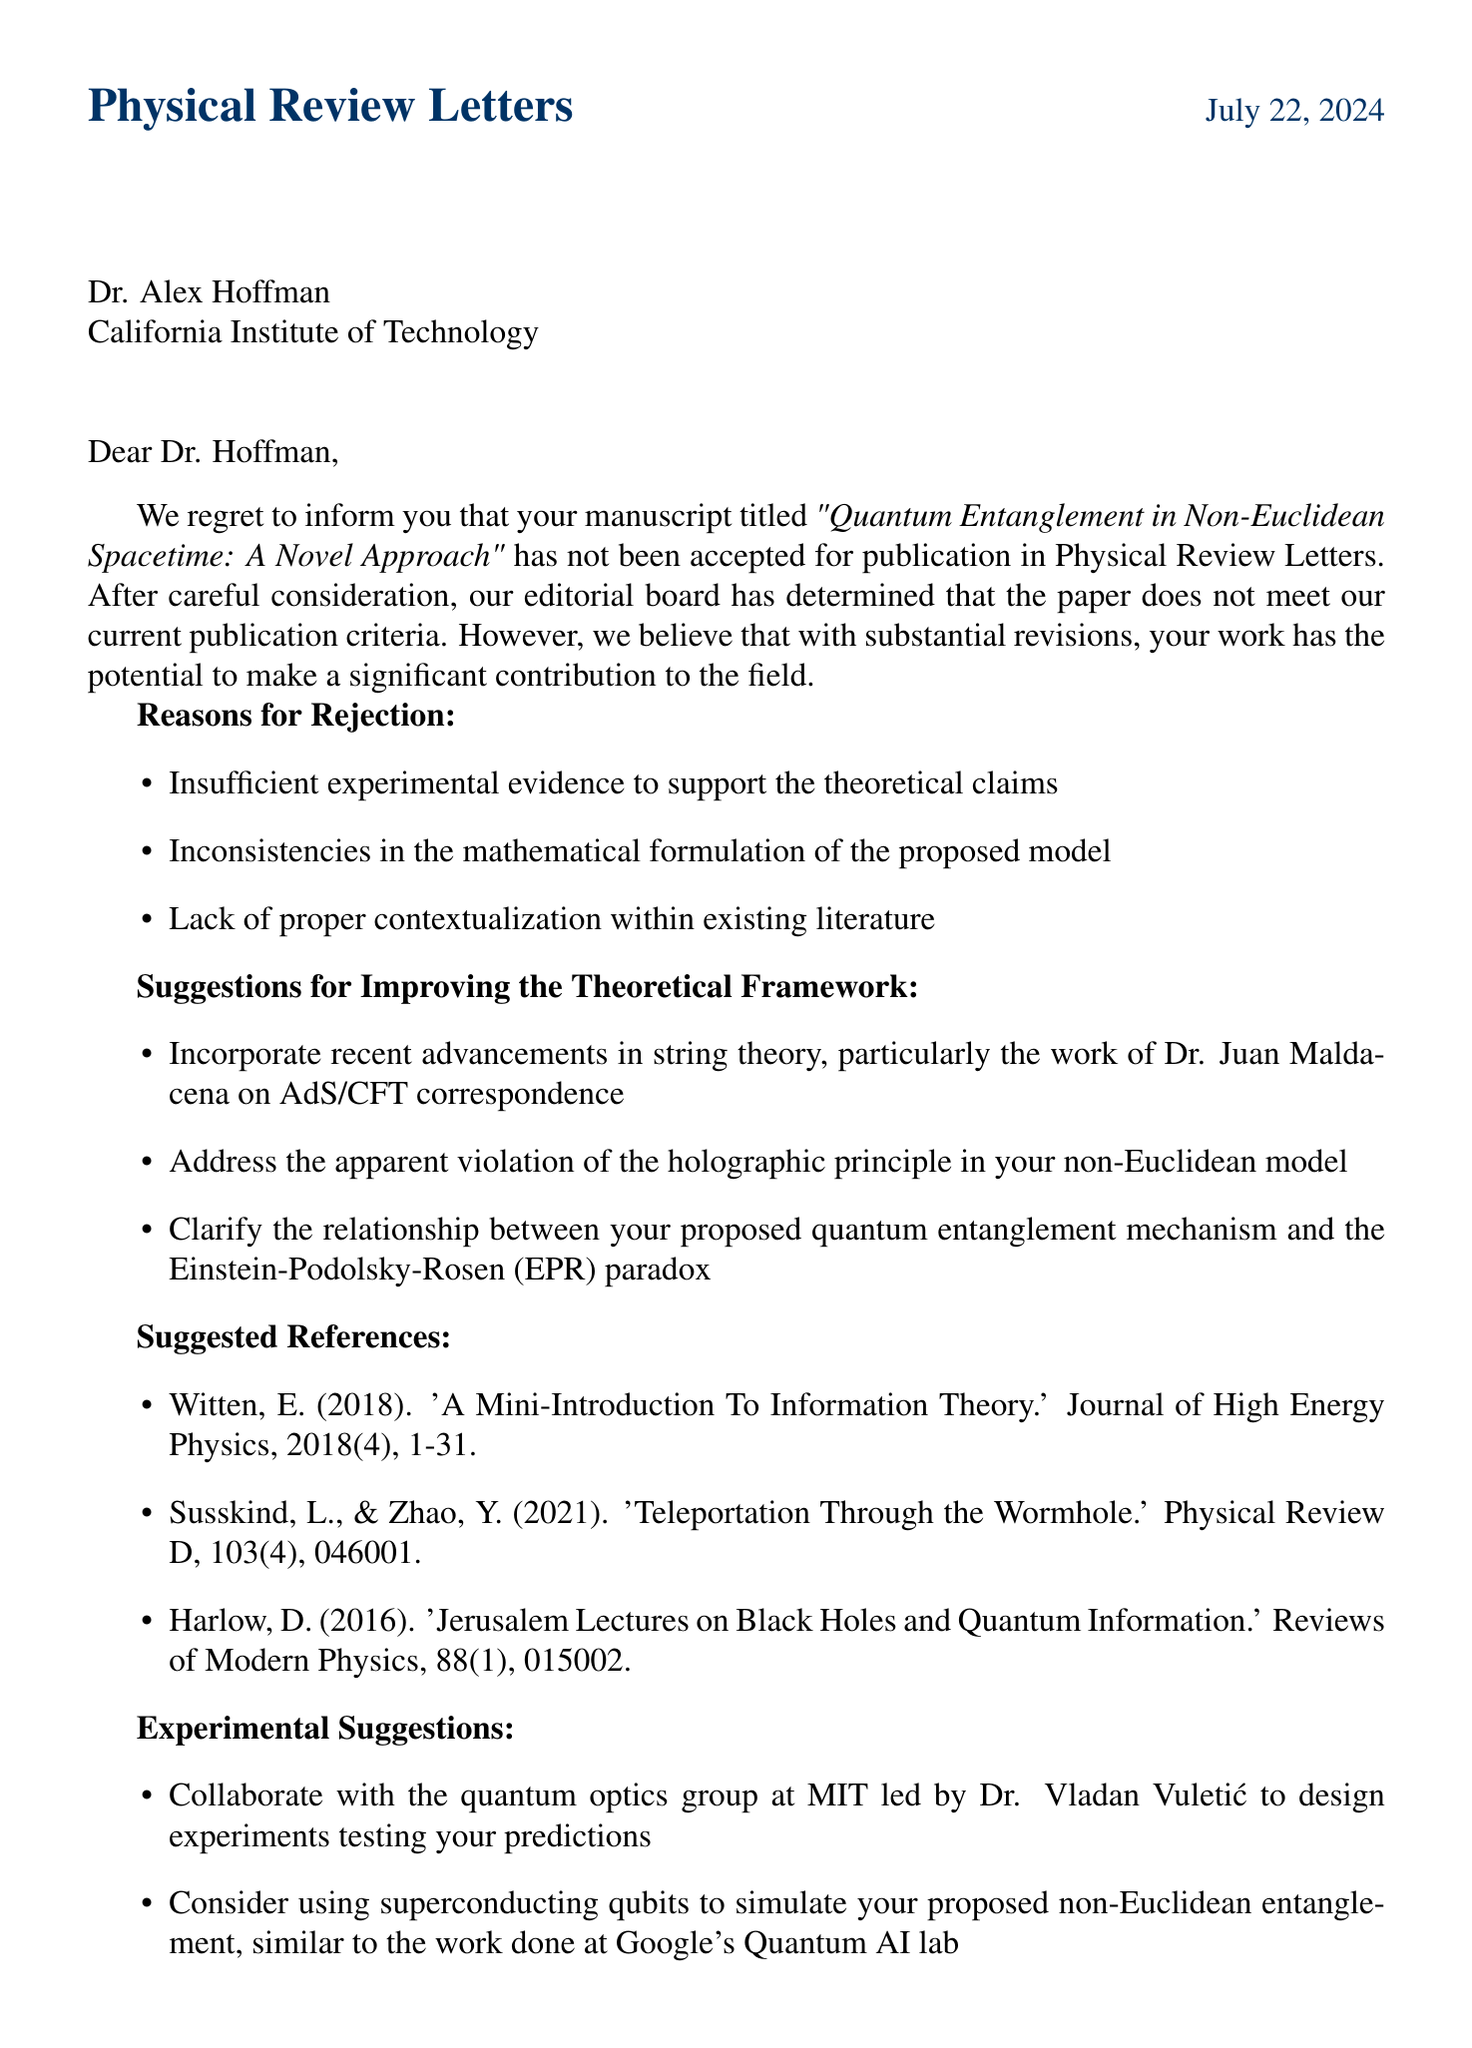What is the name of the journal? The document explicitly mentions the name of the journal where the paper was submitted, which is "Physical Review Letters."
Answer: Physical Review Letters Who is the editor of the journal? The document provides the name of the editor who reviewed the submission, which is Dr. Samantha Chen.
Answer: Dr. Samantha Chen What is the title of the paper? The title of the paper is stated in the opening paragraphs, which is "Quantum Entanglement in Non-Euclidean Spacetime: A Novel Approach."
Answer: Quantum Entanglement in Non-Euclidean Spacetime: A Novel Approach What is one of the reasons for rejection? The document lists specific reasons for the paper's rejection, one of which is "Insufficient experimental evidence to support the theoretical claims."
Answer: Insufficient experimental evidence to support the theoretical claims What is suggested to improve the theoretical framework regarding the holographic principle? The letter provides a suggestion about the theoretical framework that states to "Address the apparent violation of the holographic principle in your non-Euclidean model."
Answer: Address the apparent violation of the holographic principle in your non-Euclidean model How long is the resubmission deadline from the date of the letter? The document explicitly outlines the resubmission guidelines, specifying the deadline as "6 months from the date of this letter."
Answer: 6 months What type of model is suggested to simulate the non-Euclidean entanglement? The document specifies the use of "superconducting qubits" to simulate the proposed non-Euclidean entanglement.
Answer: superconducting qubits Which academic institution is the author affiliated with? The letter mentions the author's affiliation in the address section as "California Institute of Technology."
Answer: California Institute of Technology What is one of the alternative journals suggested? The document provides a list of alternative journals, one of which is "Nature Physics."
Answer: Nature Physics 